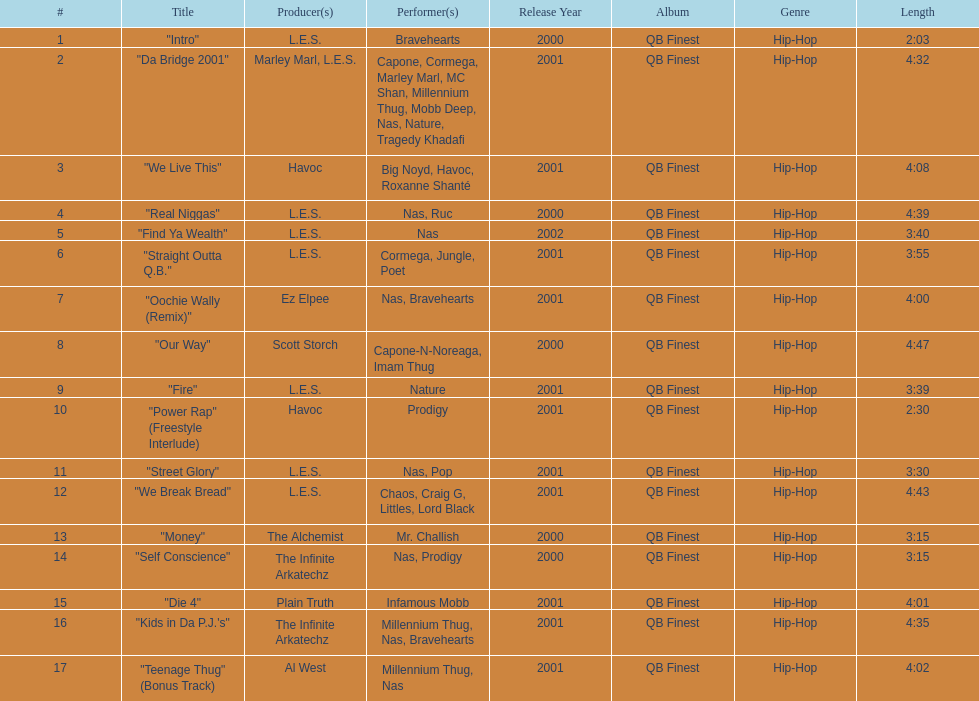What performers were in the last track? Millennium Thug, Nas. 